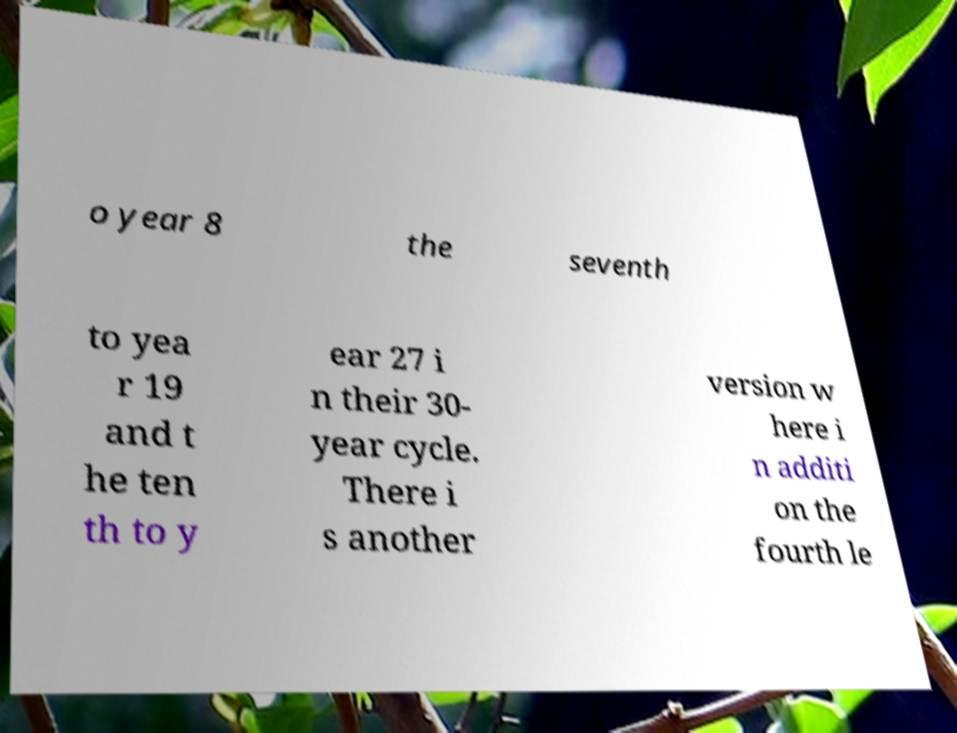For documentation purposes, I need the text within this image transcribed. Could you provide that? o year 8 the seventh to yea r 19 and t he ten th to y ear 27 i n their 30- year cycle. There i s another version w here i n additi on the fourth le 